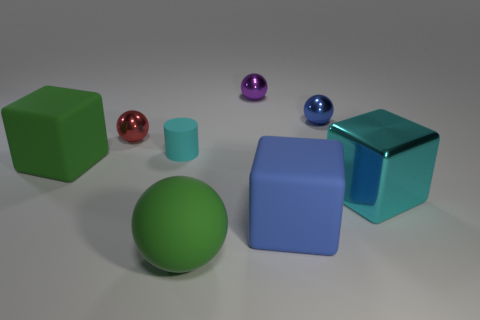Subtract all tiny spheres. How many spheres are left? 1 Subtract all green blocks. How many blocks are left? 2 Subtract all blocks. How many objects are left? 5 Add 2 large cubes. How many objects exist? 10 Subtract 1 spheres. How many spheres are left? 3 Add 8 large purple matte objects. How many large purple matte objects exist? 8 Subtract 0 gray cylinders. How many objects are left? 8 Subtract all blue balls. Subtract all purple cylinders. How many balls are left? 3 Subtract all blue cylinders. How many blue cubes are left? 1 Subtract all brown metallic cylinders. Subtract all small rubber objects. How many objects are left? 7 